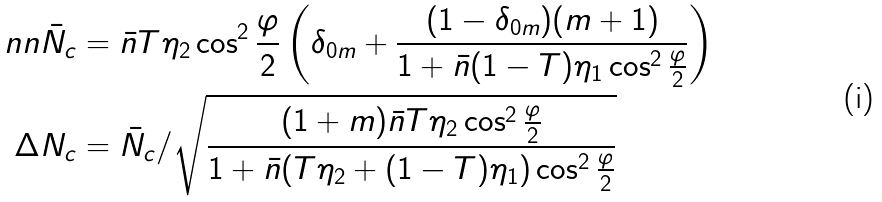Convert formula to latex. <formula><loc_0><loc_0><loc_500><loc_500>\ n n \bar { N } _ { c } & = \bar { n } T \eta _ { 2 } \cos ^ { 2 } \frac { \varphi } { 2 } \left ( \delta _ { 0 m } + \frac { ( 1 - \delta _ { 0 m } ) ( m + 1 ) } { 1 + \bar { n } ( 1 - T ) \eta _ { 1 } \cos ^ { 2 } \frac { \varphi } { 2 } } \right ) \\ \Delta N _ { c } & = \bar { N } _ { c } / \sqrt { \frac { ( 1 + m ) \bar { n } T \eta _ { 2 } \cos ^ { 2 } \frac { \varphi } { 2 } } { 1 + \bar { n } ( T \eta _ { 2 } + ( 1 - T ) \eta _ { 1 } ) \cos ^ { 2 } \frac { \varphi } { 2 } } }</formula> 